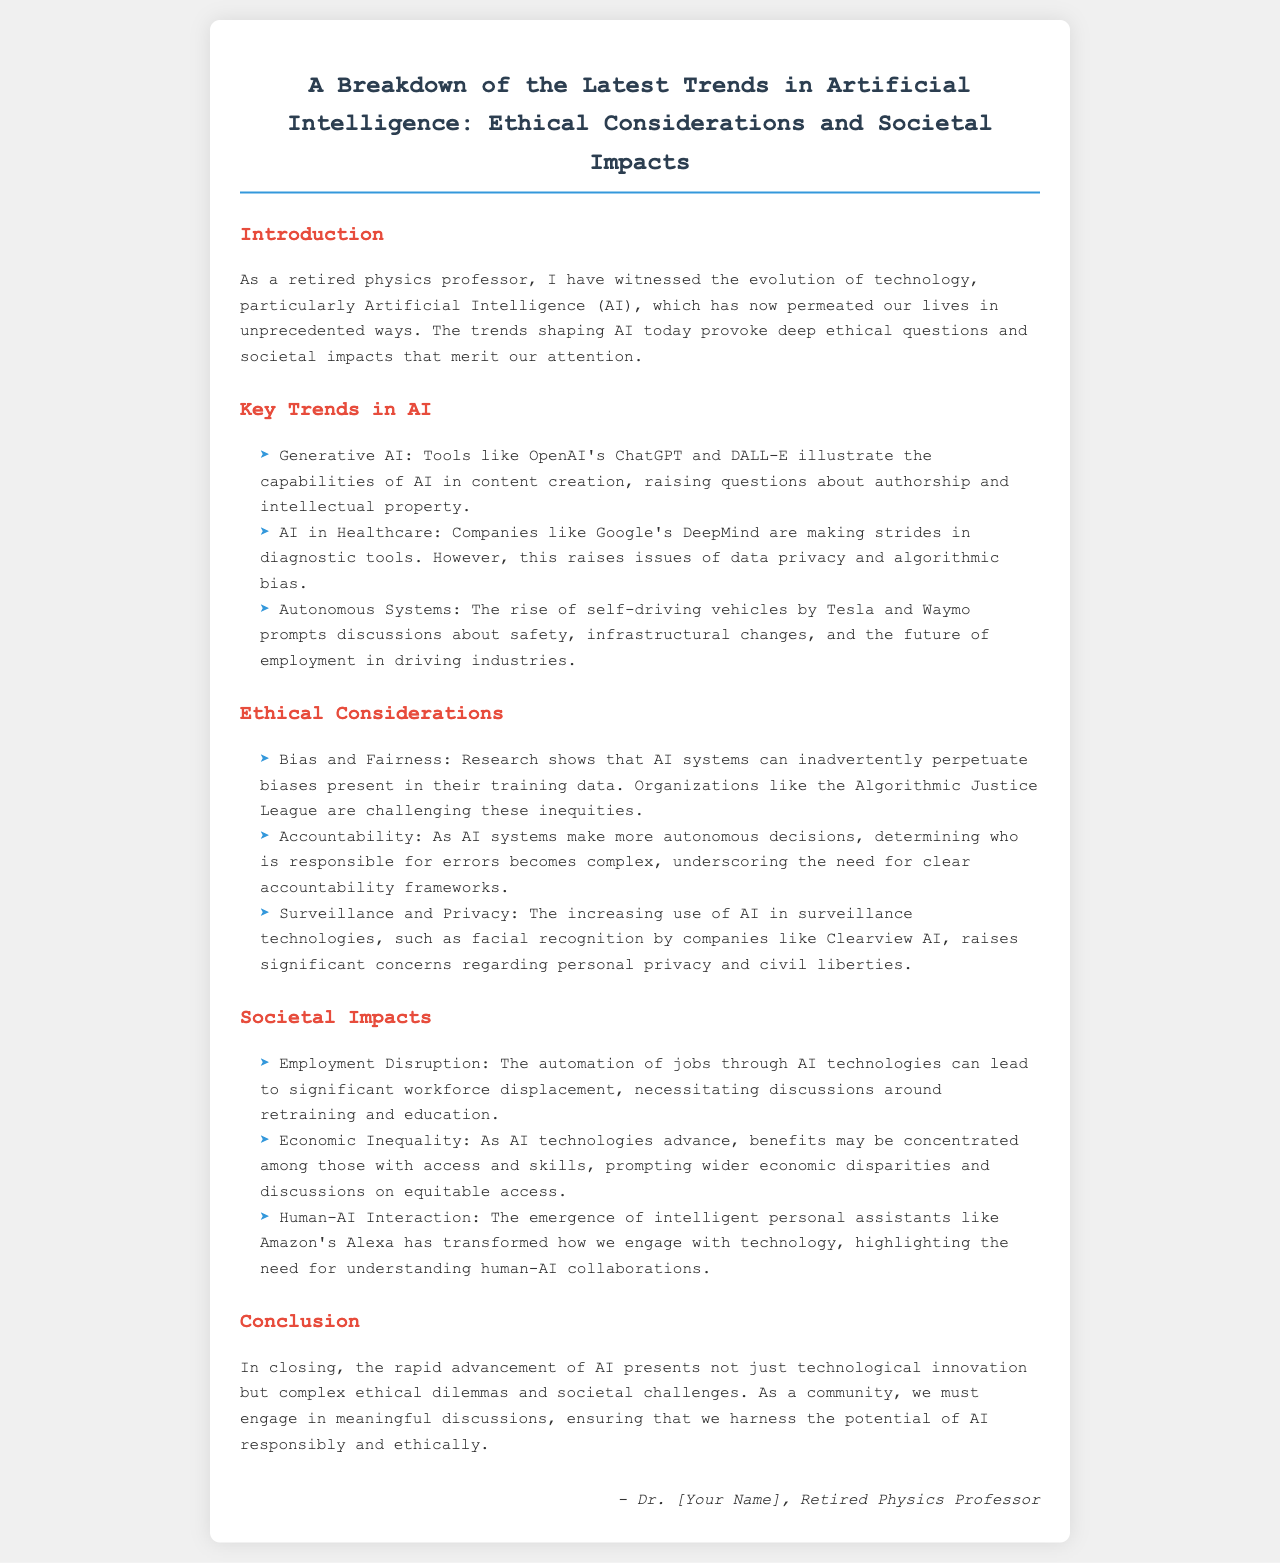What is the title of the document? The title is presented prominently at the beginning of the document, summarizing its focus on AI trends.
Answer: A Breakdown of the Latest Trends in Artificial Intelligence: Ethical Considerations and Societal Impacts Who are the companies mentioned in the AI in Healthcare trend? The companies referenced in the AI in Healthcare section include a notable example that is advancing diagnostic tools.
Answer: Google's DeepMind What ethical concern is highlighted regarding data used in AI systems? The document addresses a significant ethical issue that arises from the data that AI systems are trained on.
Answer: Bias and Fairness What societal impact is associated with job automation through AI technologies? The document outlines a critical consequence of AI in the workplace, particularly as it relates to employment.
Answer: Employment Disruption Who is mentioned as advocating for challenges against AI inequities? The document names an organization dedicated to addressing biases and inequities in AI systems.
Answer: Algorithmic Justice League What is emphasized as necessary due to the rise of autonomous decision-making in AI? The text underlines a crucial need resulting from AI's increasing autonomy in decision-making processes.
Answer: Clear accountability frameworks How does the document describe the interaction between humans and AI? The societal impacts section highlights how recent technology changes have affected people's engagement with machines.
Answer: Human-AI Interaction What is a key trend in AI that relates to content creation? The document identifies a specific AI trend that pertains to generating various types of media.
Answer: Generative AI 